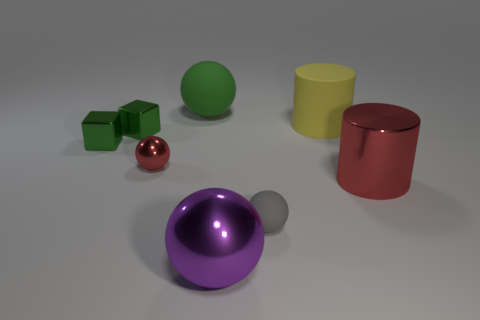Subtract 1 balls. How many balls are left? 3 Add 1 large red cubes. How many objects exist? 9 Subtract all blocks. How many objects are left? 6 Subtract all brown cylinders. Subtract all green balls. How many objects are left? 7 Add 3 small cubes. How many small cubes are left? 5 Add 3 rubber balls. How many rubber balls exist? 5 Subtract 0 yellow spheres. How many objects are left? 8 